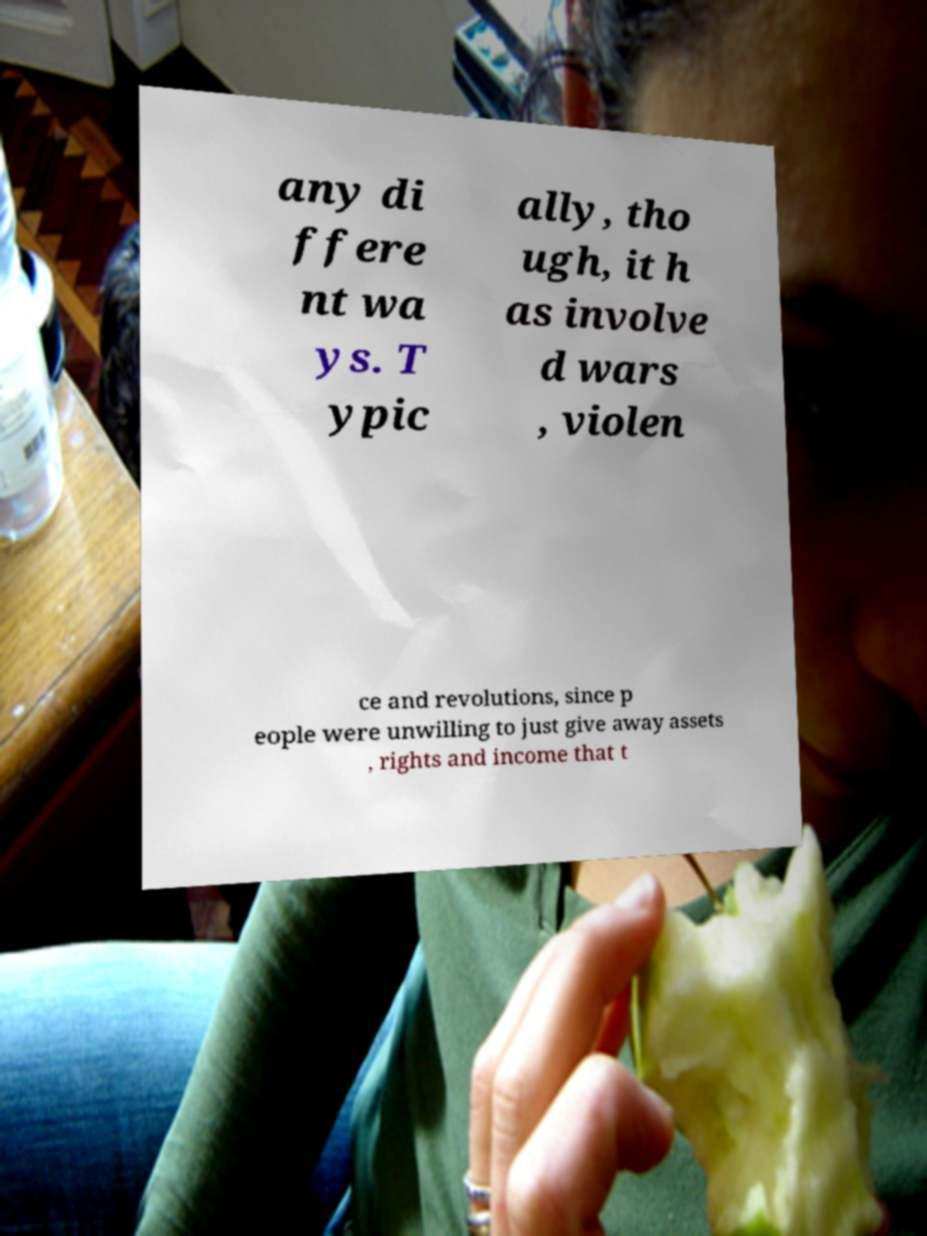There's text embedded in this image that I need extracted. Can you transcribe it verbatim? any di ffere nt wa ys. T ypic ally, tho ugh, it h as involve d wars , violen ce and revolutions, since p eople were unwilling to just give away assets , rights and income that t 